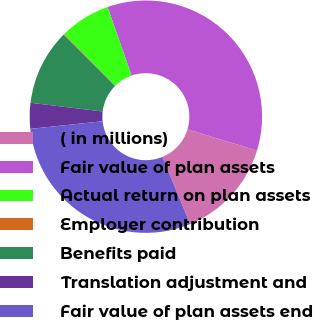<chart> <loc_0><loc_0><loc_500><loc_500><pie_chart><fcel>( in millions)<fcel>Fair value of plan assets<fcel>Actual return on plan assets<fcel>Employer contribution<fcel>Benefits paid<fcel>Translation adjustment and<fcel>Fair value of plan assets end<nl><fcel>14.07%<fcel>35.05%<fcel>7.08%<fcel>0.09%<fcel>10.58%<fcel>3.58%<fcel>29.55%<nl></chart> 